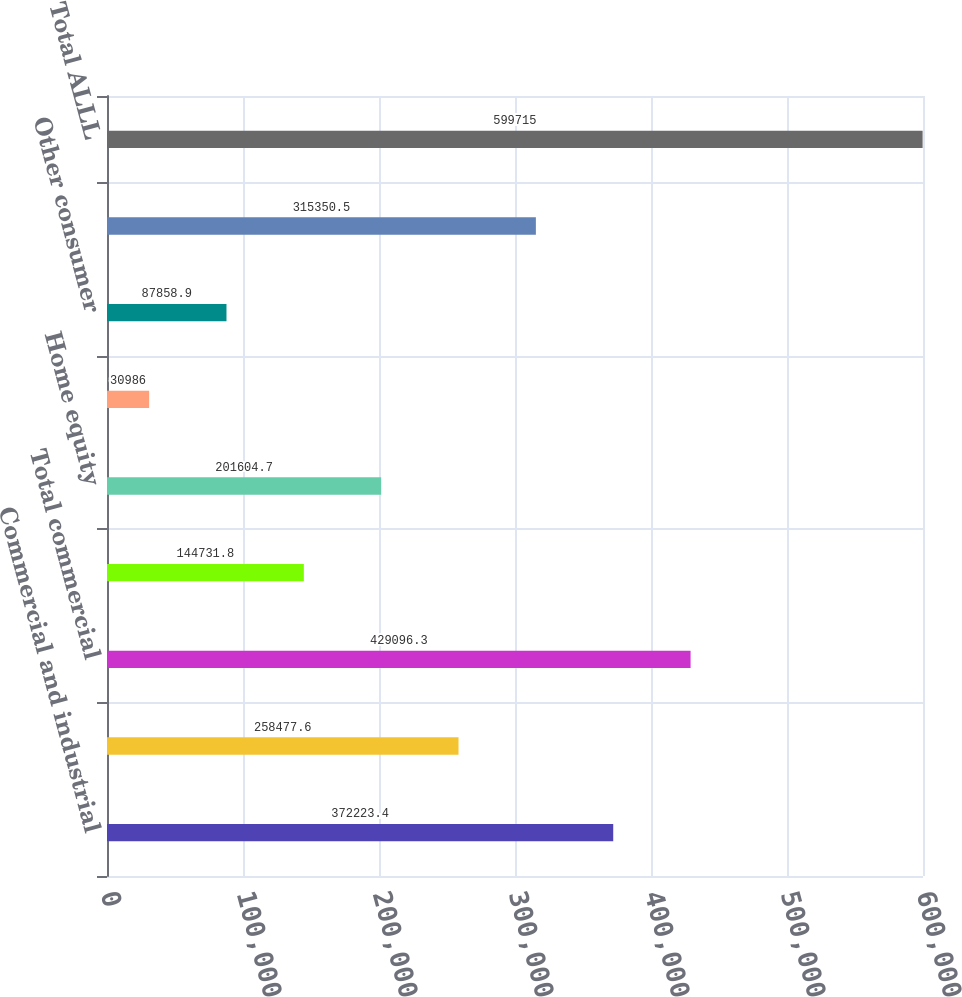Convert chart. <chart><loc_0><loc_0><loc_500><loc_500><bar_chart><fcel>Commercial and industrial<fcel>Commercial real estate<fcel>Total commercial<fcel>Automobile<fcel>Home equity<fcel>Residential mortgage<fcel>Other consumer<fcel>Total consumer<fcel>Total ALLL<nl><fcel>372223<fcel>258478<fcel>429096<fcel>144732<fcel>201605<fcel>30986<fcel>87858.9<fcel>315350<fcel>599715<nl></chart> 